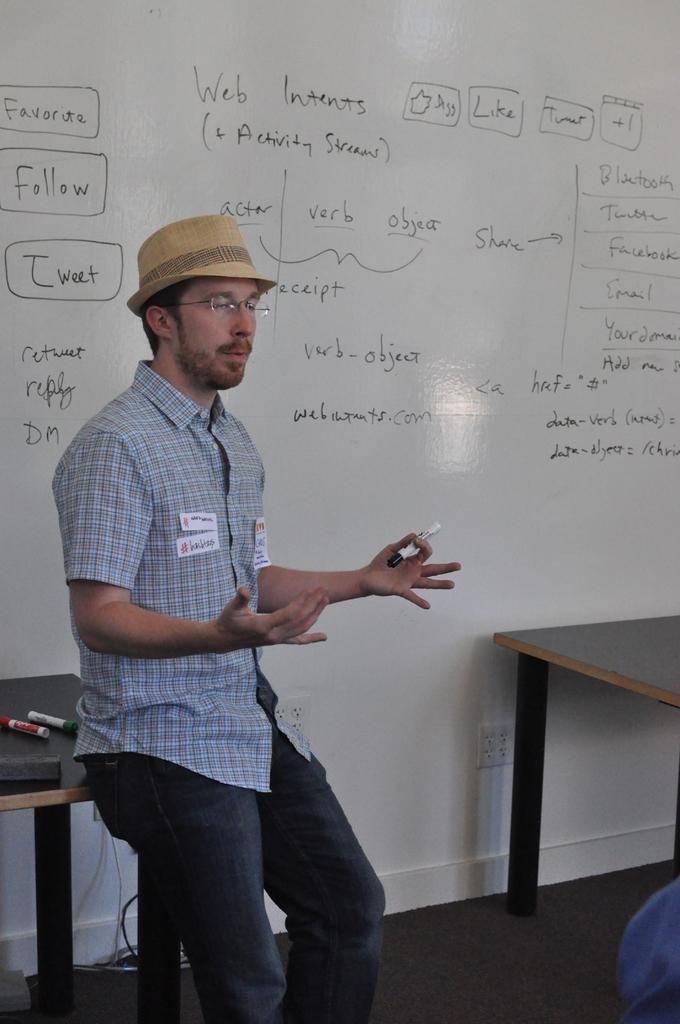Provide a one-sentence caption for the provided image. A man is in the front of a room with writing on the wall behind him such as Web Intents (+ Activity Streams). 